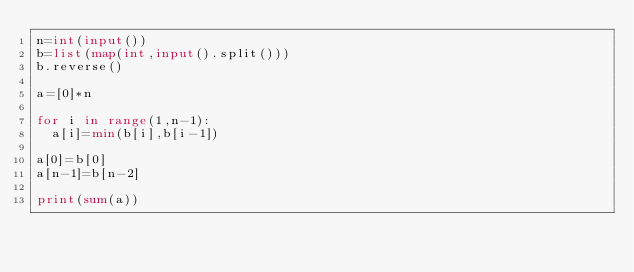<code> <loc_0><loc_0><loc_500><loc_500><_Python_>n=int(input())
b=list(map(int,input().split()))
b.reverse()

a=[0]*n

for i in range(1,n-1):
  a[i]=min(b[i],b[i-1])

a[0]=b[0]
a[n-1]=b[n-2]

print(sum(a))</code> 